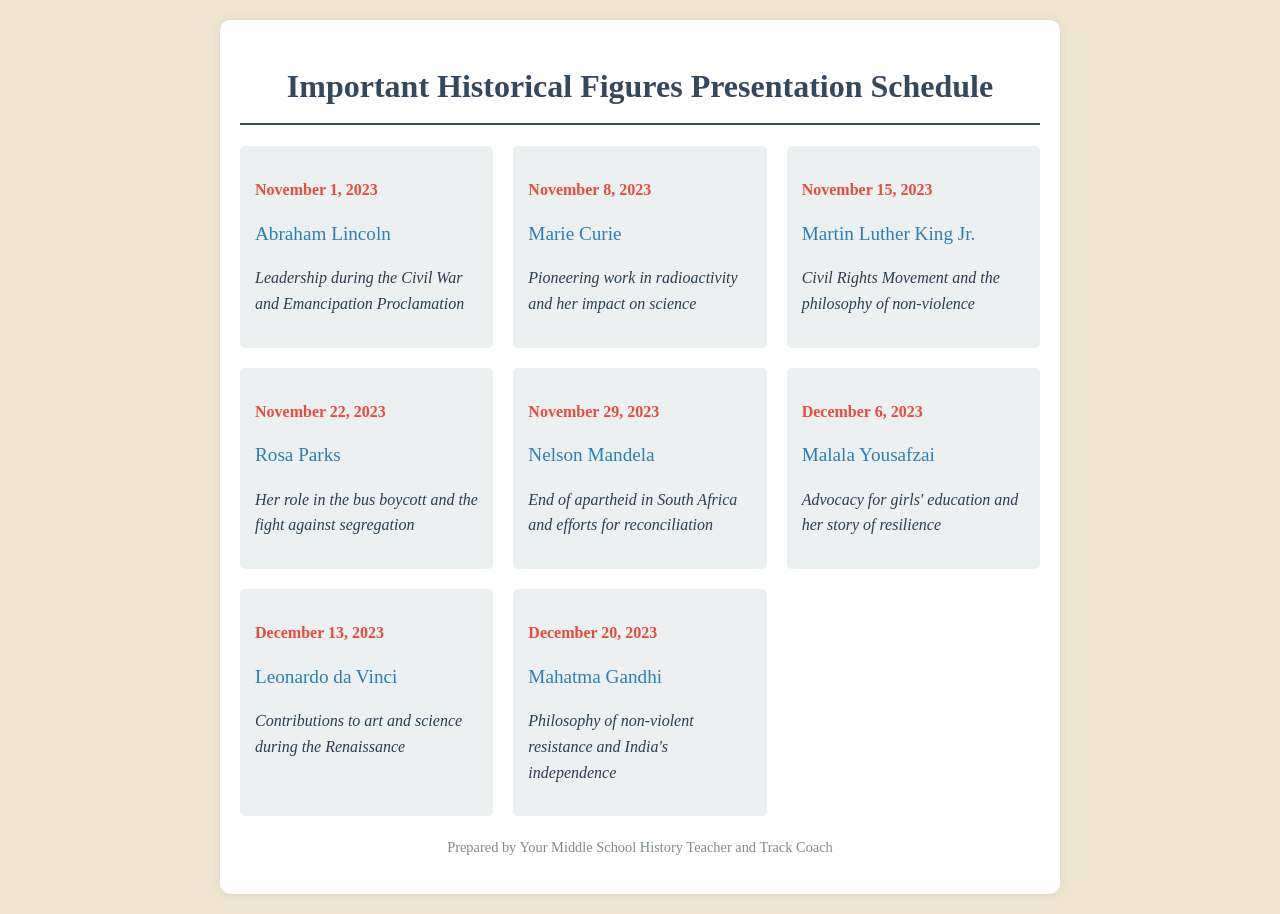What is the date for the presentation on Abraham Lincoln? The date for the presentation on Abraham Lincoln is clearly listed, which is November 1, 2023.
Answer: November 1, 2023 Who is presenting on December 6, 2023? The schedule shows that Malala Yousafzai will be presenting on December 6, 2023.
Answer: Malala Yousafzai What significant impact is associated with Nelson Mandela? The focus for Nelson Mandela specifically states his efforts in ending apartheid and reconciliation in South Africa.
Answer: End of apartheid Which historical figure is associated with the Civil Rights Movement? The document indicates that Martin Luther King Jr. is the historical figure related to the Civil Rights Movement.
Answer: Martin Luther King Jr How many total presentations are scheduled? By counting the individual schedule items in the document, one can determine the total number of presentations is eight.
Answer: Eight What philosophical approach is highlighted for Mahatma Gandhi? The schedule mentions Gandhi's philosophy of non-violent resistance as a significant aspect of his legacy.
Answer: Non-violent resistance When is the presentation about Rosa Parks scheduled? The document provides the specific date for Rosa Parks' presentation, which is November 22, 2023.
Answer: November 22, 2023 Which two figures focus on education in their presentations? The presentations of Marie Curie and Malala Yousafzai are both associated with significant contributions to education and science.
Answer: Marie Curie, Malala Yousafzai 